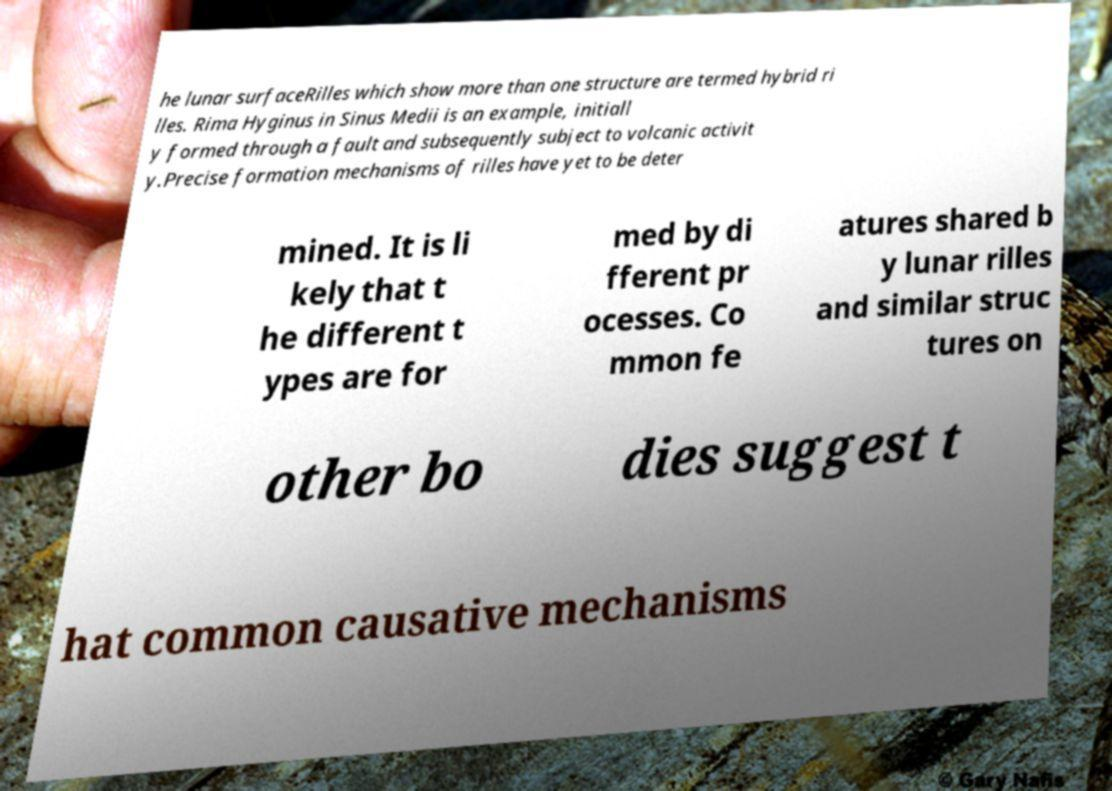Can you read and provide the text displayed in the image?This photo seems to have some interesting text. Can you extract and type it out for me? he lunar surfaceRilles which show more than one structure are termed hybrid ri lles. Rima Hyginus in Sinus Medii is an example, initiall y formed through a fault and subsequently subject to volcanic activit y.Precise formation mechanisms of rilles have yet to be deter mined. It is li kely that t he different t ypes are for med by di fferent pr ocesses. Co mmon fe atures shared b y lunar rilles and similar struc tures on other bo dies suggest t hat common causative mechanisms 